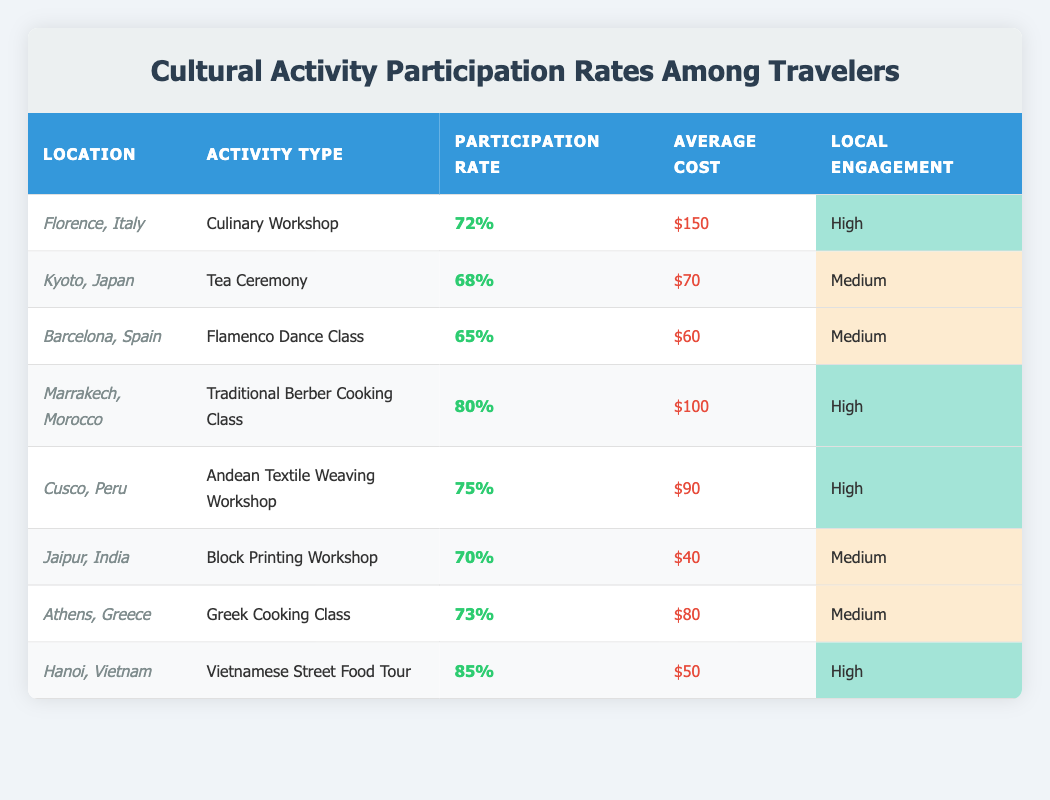What is the highest participation rate? The table lists various cultural activities and their participation rates. By examining the percentage values, the maximum participation rate is found to be 85% for the Vietnamese Street Food Tour in Hanoi, Vietnam.
Answer: 85% Which activity has the lowest average cost? The table shows the average costs for various activities. By comparing the values, the Block Printing Workshop in Jaipur, India has the lowest average cost at $40.
Answer: $40 Is the participation rate for the Traditional Berber Cooking Class higher than for the Greek Cooking Class? Based on the table, the participation rate for the Traditional Berber Cooking Class is 80%, while for the Greek Cooking Class, it is 73%. Since 80% is greater than 73%, the statement is true.
Answer: Yes What is the average participation rate of activities with high local engagement? The table indicates that activities with high local engagement include the Culinary Workshop (72%), Traditional Berber Cooking Class (80%), Andean Textile Weaving Workshop (75%), Vietnamese Street Food Tour (85%). To find the average, we add these rates (72 + 80 + 75 + 85 = 312) and divide by the number of activities (312 / 4 = 78).
Answer: 78% Are there more activities with medium local engagement than high local engagement? Looking at the table, there are three activities with medium local engagement (Tea Ceremony, Flamenco Dance Class, Block Printing Workshop, Greek Cooking Class) and four with high local engagement (Culinary Workshop, Traditional Berber Cooking Class, Andean Textile Weaving Workshop, Vietnamese Street Food Tour). Since 3 is not greater than 4, the statement is false.
Answer: No What is the total average cost of activities in Spain and Morocco? The average cost of the Flamenco Dance Class in Spain is $60, and the Traditional Berber Cooking Class in Morocco is $100. Adding these costs (60 + 100 = 160) gives a total of $160. To find the average, we divide by 2 (160 / 2 = 80).
Answer: 80 How many activities have a participation rate of 70% or above? By checking the participation rates in the table, they are 72% (Florence), 80% (Marrakech), 75% (Cusco), 70% (Jaipur), 73% (Athens), and 85% (Hanoi). Counting these, there are 6 activities with a participation rate of 70% or more.
Answer: 6 Which country has the highest local engagement level for its activity? The table shows local engagement levels, with Vietnam and Morocco both listed as high. However, the activity in Morocco (Traditional Berber Cooking Class) has a higher participation rate (80%) compared to Vietnamese Street Food Tour (85%). Therefore, although both have high engagement, the activity participation distinguishes them.
Answer: Morocco 